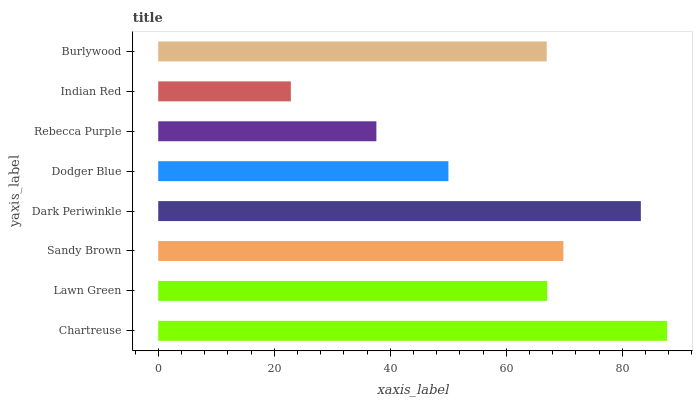Is Indian Red the minimum?
Answer yes or no. Yes. Is Chartreuse the maximum?
Answer yes or no. Yes. Is Lawn Green the minimum?
Answer yes or no. No. Is Lawn Green the maximum?
Answer yes or no. No. Is Chartreuse greater than Lawn Green?
Answer yes or no. Yes. Is Lawn Green less than Chartreuse?
Answer yes or no. Yes. Is Lawn Green greater than Chartreuse?
Answer yes or no. No. Is Chartreuse less than Lawn Green?
Answer yes or no. No. Is Lawn Green the high median?
Answer yes or no. Yes. Is Burlywood the low median?
Answer yes or no. Yes. Is Dodger Blue the high median?
Answer yes or no. No. Is Sandy Brown the low median?
Answer yes or no. No. 